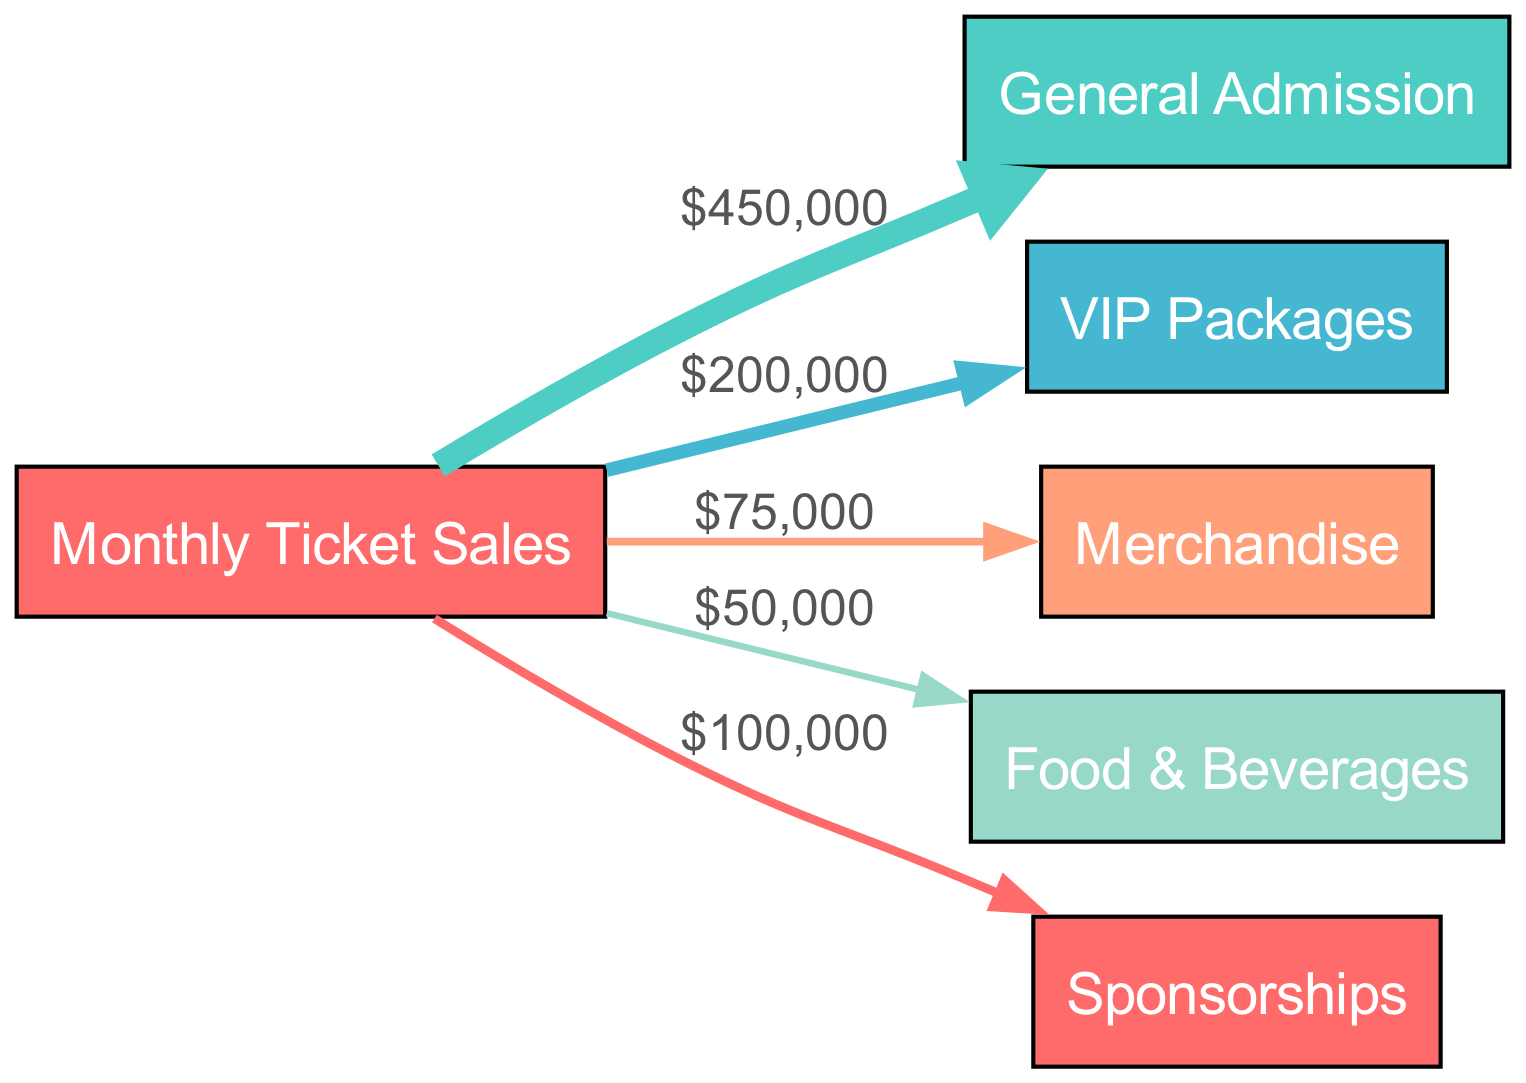What is the total revenue generated from all sources? To find the total revenue, we sum the values from all revenue sources shown in the diagram: General Admission (450000) + VIP Packages (200000) + Merchandise (75000) + Food & Beverages (50000) + Sponsorships (100000) = 875000.
Answer: 875000 How much revenue does the 'VIP Packages' node generate? By directly looking at the 'VIP Packages' node in the diagram, we see that it has a value of 200000 associated with it.
Answer: 200000 Which revenue source has the highest amount in the diagram? We compare all the values of the revenue sources: General Admission (450000), VIP Packages (200000), Merchandise (75000), Food & Beverages (50000), and Sponsorships (100000). The highest value is from General Admission, which is 450000.
Answer: General Admission What is the total of General Admission and VIP Packages? We take the values of both nodes: General Admission (450000) + VIP Packages (200000) = 650000.
Answer: 650000 What proportion of the total revenue comes from Merchandise? The revenue from Merchandise is 75000. The total revenue is 875000. To find the proportion, we calculate (75000 / 875000) * 100, which is approximately 8.57%.
Answer: 8.57% Which two sources have the least revenue? From the diagram, we can see that Food & Beverages has 50000 and Merchandise has 75000. Comparing these two, Food & Beverages has the least revenue. Hence, the two sources with the least revenue are Food & Beverages and Merchandise.
Answer: Food & Beverages, Merchandise What is the value of the link from Monthly Ticket Sales to Sponsorships? The link from Monthly Ticket Sales to Sponsorships shows a value of 100000 in the diagram.
Answer: 100000 What is the combined revenue from Food & Beverages and Sponsorships? We add the values for those two nodes: Food & Beverages (50000) + Sponsorships (100000) = 150000.
Answer: 150000 Which node represents the summary of sales from all other nodes? The node labeled 'Monthly Ticket Sales' represents the summary of the sales from all other nodes that flow into it.
Answer: Monthly Ticket Sales What is the total amount from General Admission and Merchandise combined? Adding the amounts for General Admission (450000) and Merchandise (75000): 450000 + 75000 equals 525000.
Answer: 525000 